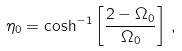<formula> <loc_0><loc_0><loc_500><loc_500>\eta _ { 0 } = \cosh ^ { - 1 } \left [ \frac { 2 - \Omega _ { 0 } } { \Omega _ { 0 } } \right ] \, ,</formula> 